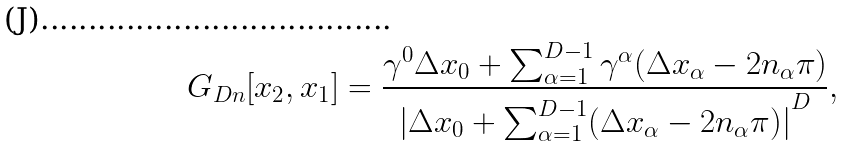<formula> <loc_0><loc_0><loc_500><loc_500>G _ { D n } [ x _ { 2 } , x _ { 1 } ] = \frac { \gamma ^ { 0 } \Delta x _ { 0 } + \sum _ { \alpha = 1 } ^ { D - 1 } \gamma ^ { \alpha } ( \Delta x _ { \alpha } - 2 n _ { \alpha } \pi ) } { { | { \Delta x _ { 0 } + \sum _ { \alpha = 1 } ^ { D - 1 } ( \Delta x _ { \alpha } - 2 n _ { \alpha } \pi ) } | } ^ { D } } ,</formula> 